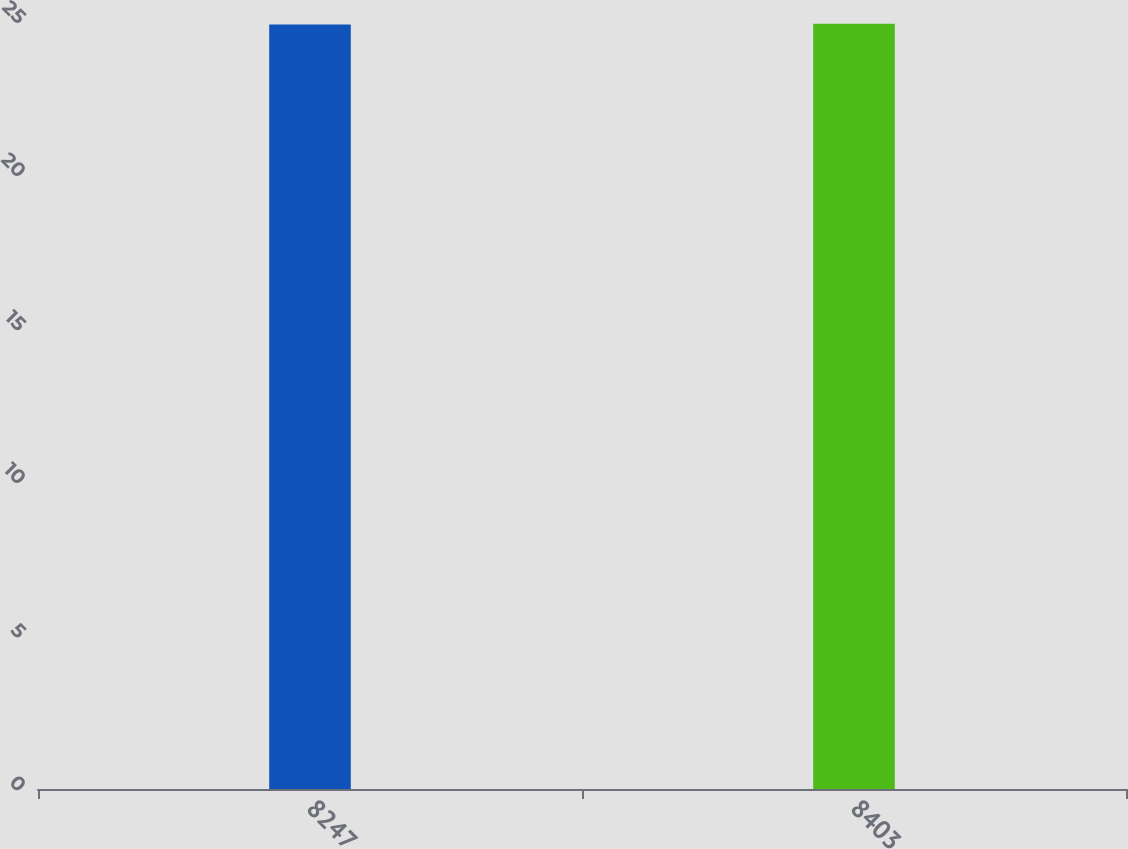<chart> <loc_0><loc_0><loc_500><loc_500><bar_chart><fcel>8247<fcel>8403<nl><fcel>24.89<fcel>24.91<nl></chart> 